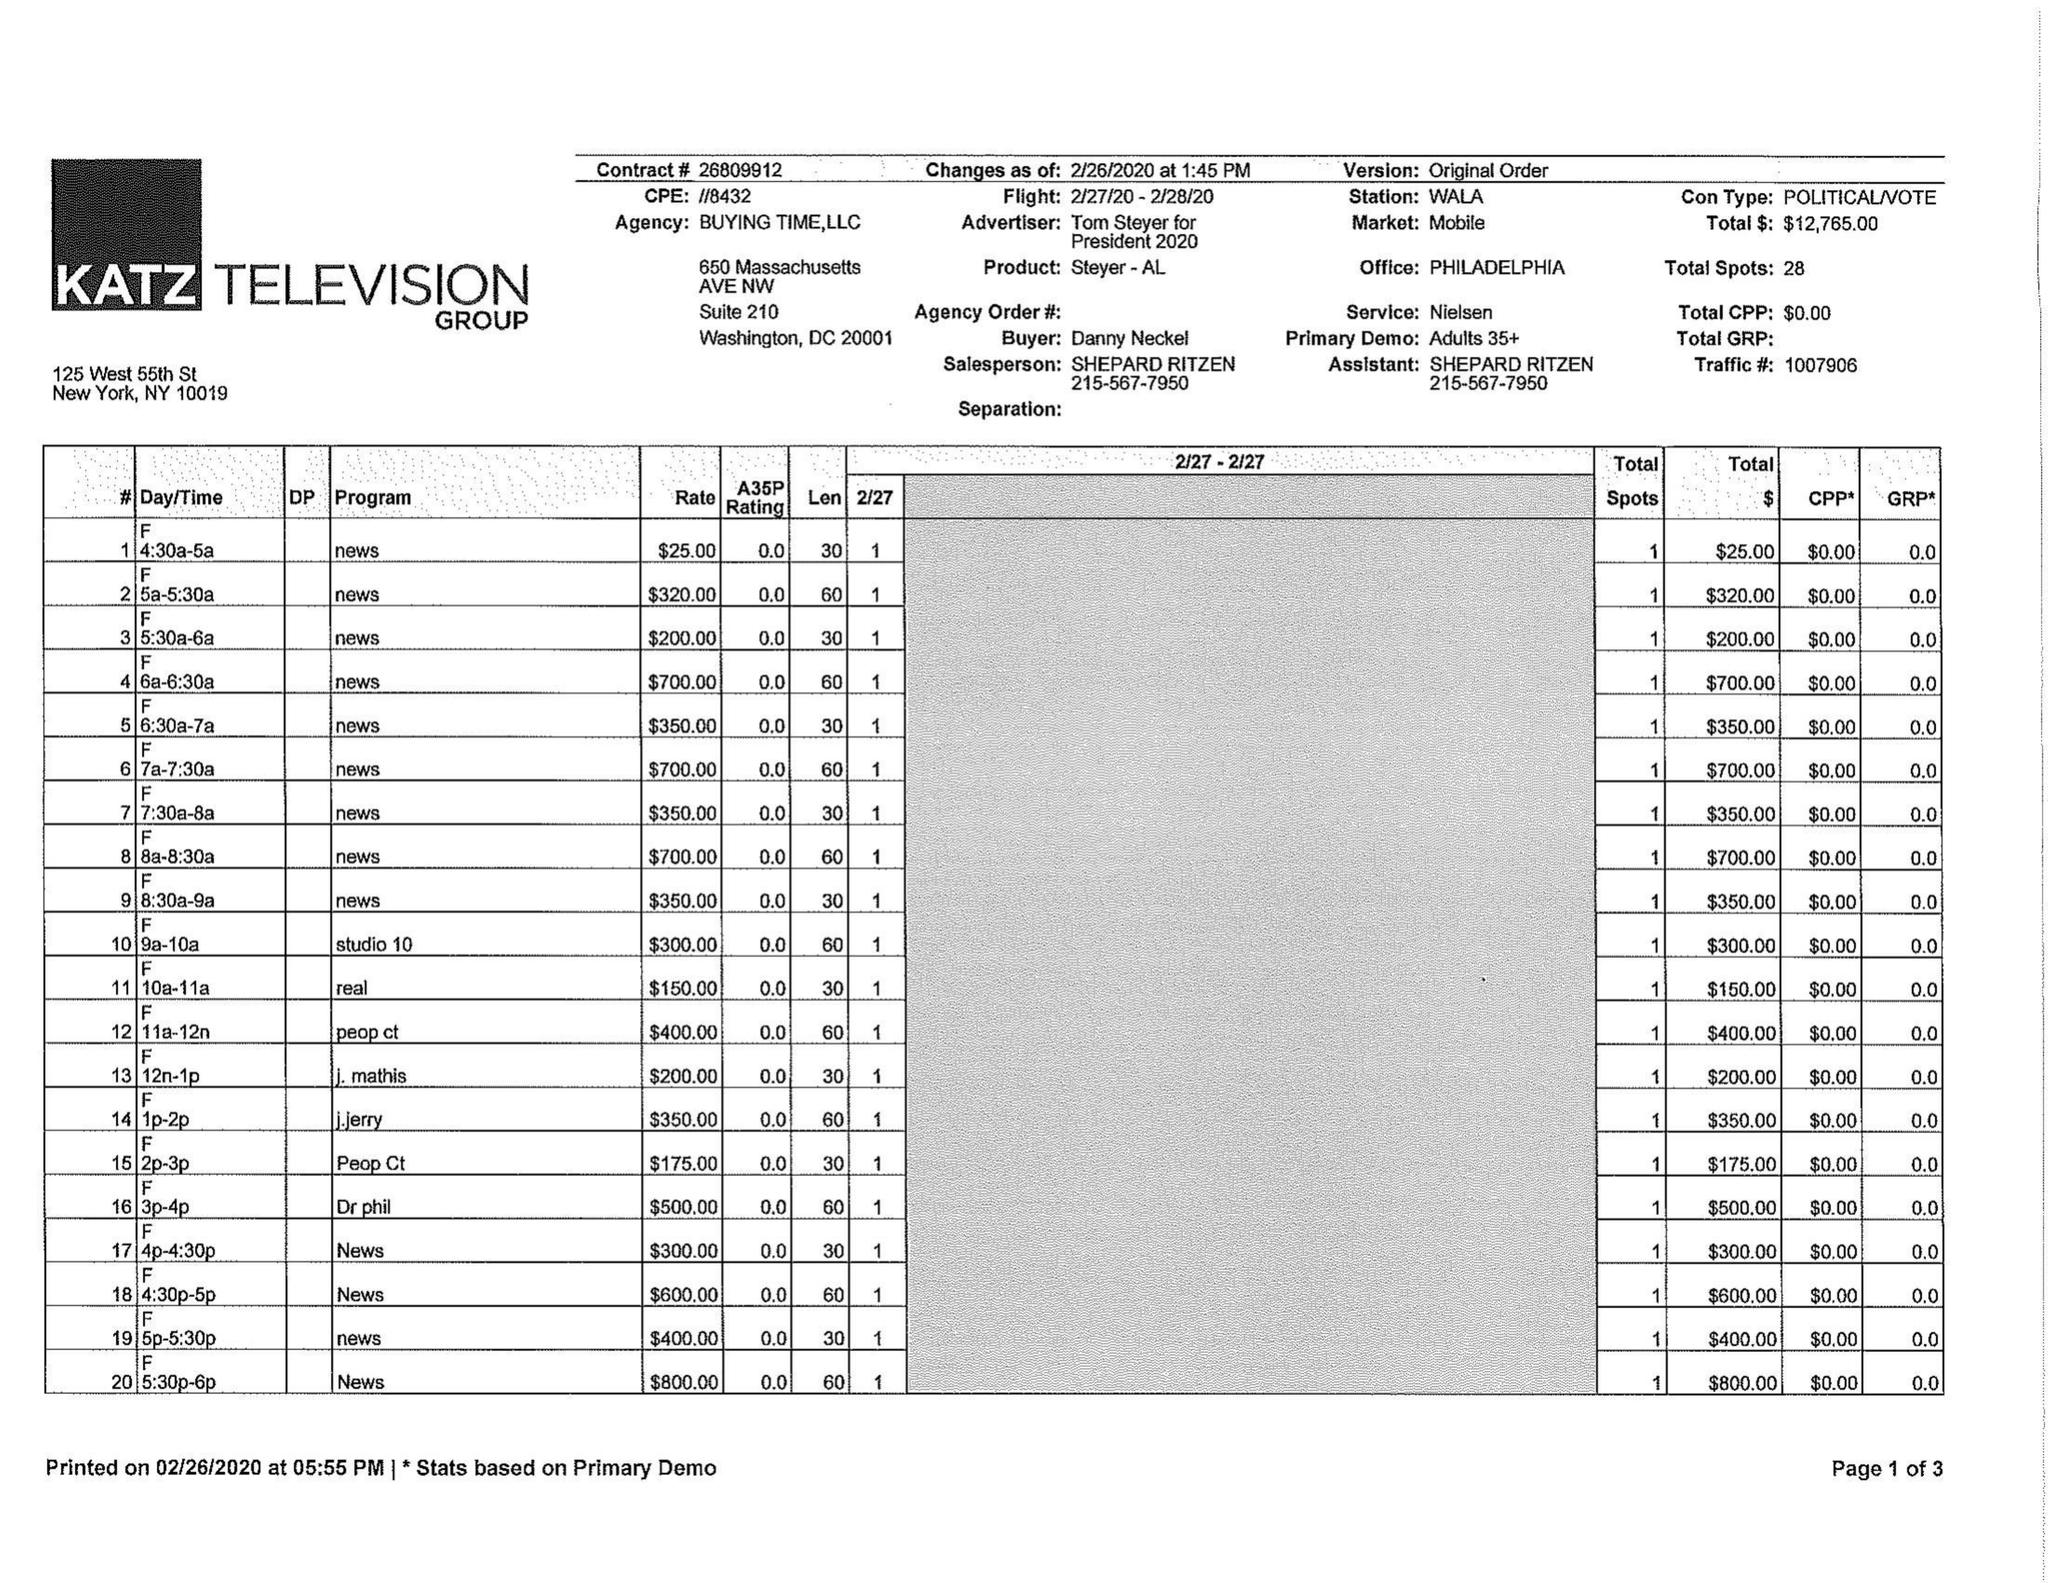What is the value for the advertiser?
Answer the question using a single word or phrase. TOM STEYER FOR PRESIDENT 2020 